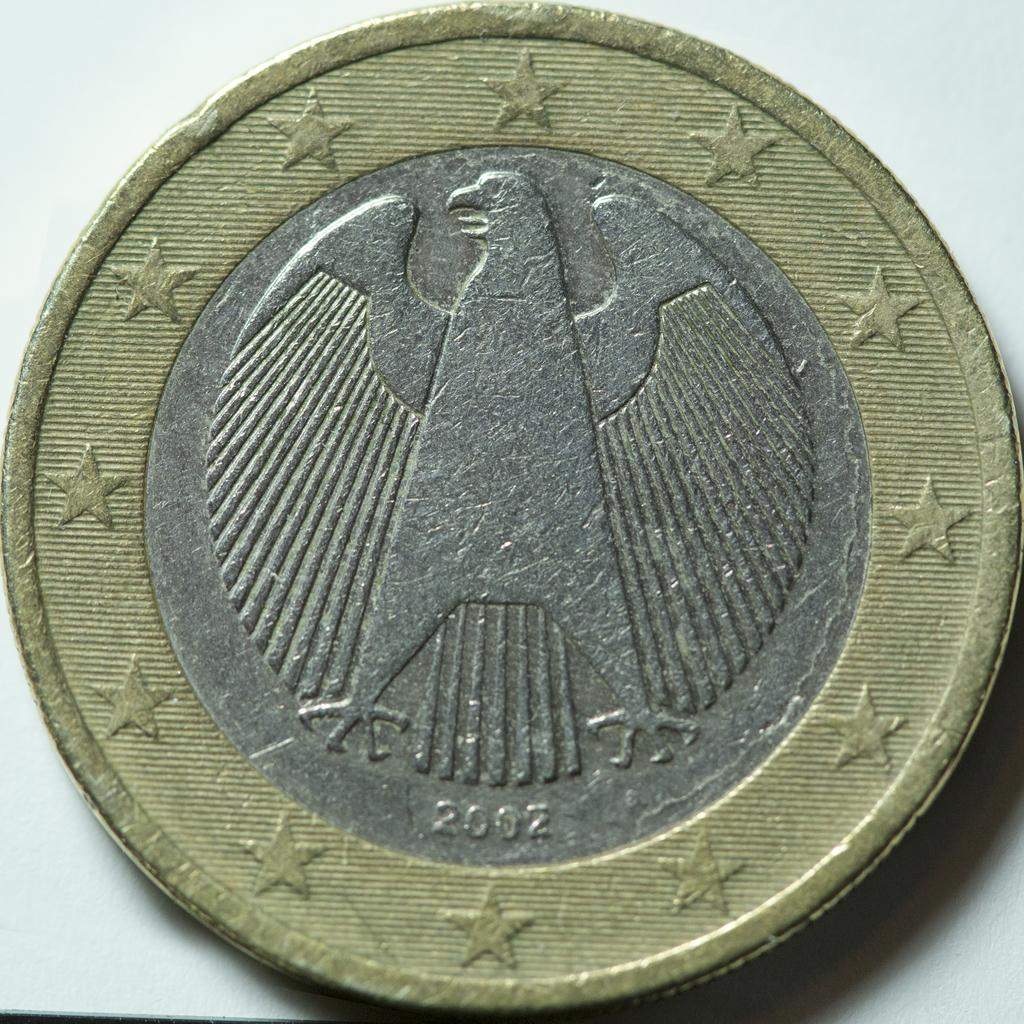<image>
Summarize the visual content of the image. A closeup of a coin with the year 2002 engraved on it 